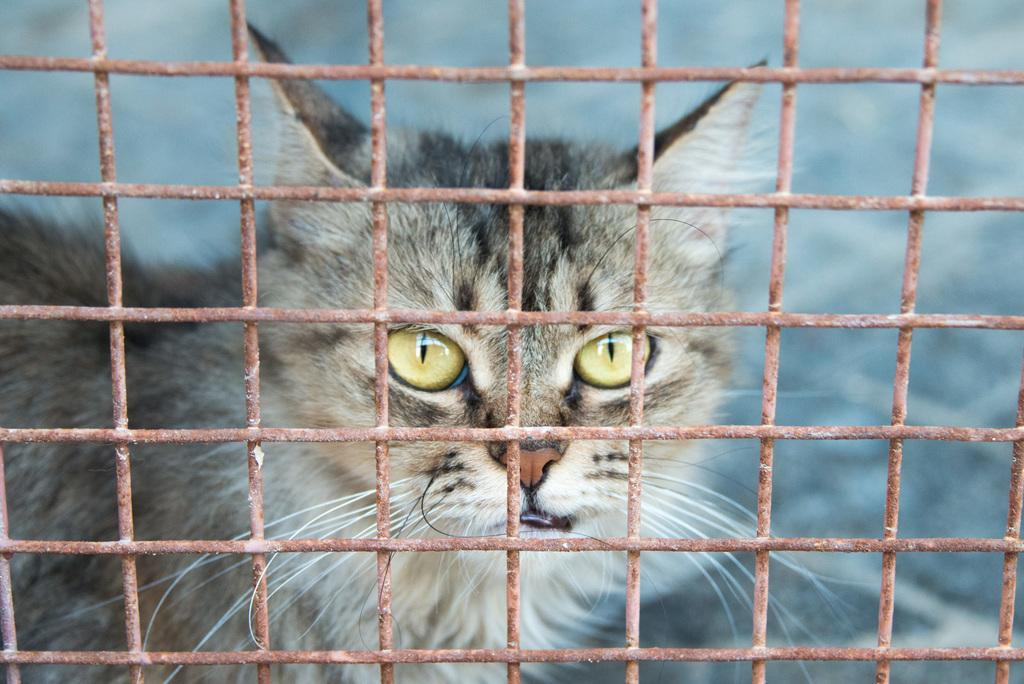Where was the image taken? The image was taken outdoors. What can be seen in the image besides the outdoor setting? There is a mesh in the image. What is behind the mesh? There is a cat behind the mesh. What nation is the minister from in the image? There is no nation or minister present in the image; it features a cat behind a mesh outdoors. 